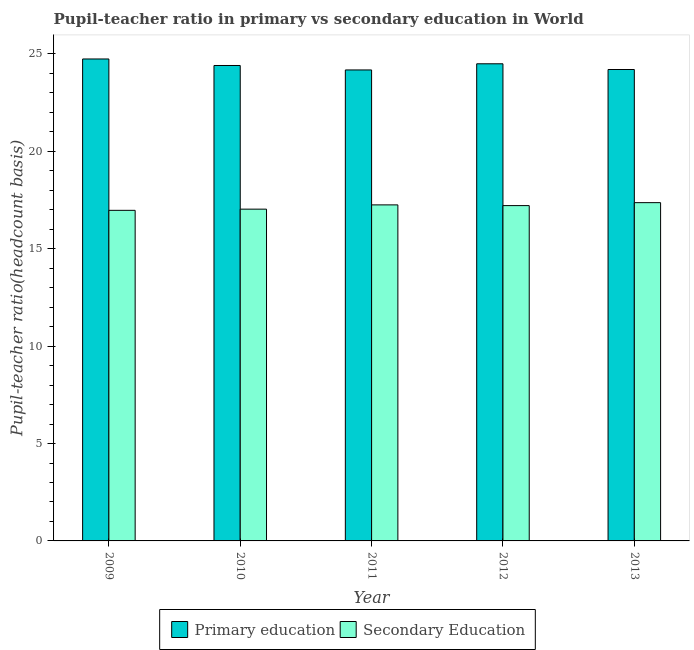How many different coloured bars are there?
Provide a short and direct response. 2. Are the number of bars per tick equal to the number of legend labels?
Ensure brevity in your answer.  Yes. Are the number of bars on each tick of the X-axis equal?
Your answer should be very brief. Yes. How many bars are there on the 4th tick from the right?
Offer a very short reply. 2. What is the pupil-teacher ratio in primary education in 2012?
Offer a terse response. 24.49. Across all years, what is the maximum pupil-teacher ratio in primary education?
Your answer should be very brief. 24.74. Across all years, what is the minimum pupil teacher ratio on secondary education?
Make the answer very short. 16.97. In which year was the pupil-teacher ratio in primary education minimum?
Offer a very short reply. 2011. What is the total pupil-teacher ratio in primary education in the graph?
Give a very brief answer. 122.02. What is the difference between the pupil-teacher ratio in primary education in 2009 and that in 2011?
Give a very brief answer. 0.56. What is the difference between the pupil teacher ratio on secondary education in 2009 and the pupil-teacher ratio in primary education in 2010?
Provide a succinct answer. -0.06. What is the average pupil teacher ratio on secondary education per year?
Give a very brief answer. 17.17. In how many years, is the pupil-teacher ratio in primary education greater than 7?
Provide a short and direct response. 5. What is the ratio of the pupil-teacher ratio in primary education in 2012 to that in 2013?
Your answer should be compact. 1.01. Is the difference between the pupil teacher ratio on secondary education in 2009 and 2012 greater than the difference between the pupil-teacher ratio in primary education in 2009 and 2012?
Give a very brief answer. No. What is the difference between the highest and the second highest pupil teacher ratio on secondary education?
Your response must be concise. 0.12. What is the difference between the highest and the lowest pupil-teacher ratio in primary education?
Make the answer very short. 0.56. What does the 2nd bar from the left in 2012 represents?
Give a very brief answer. Secondary Education. What does the 2nd bar from the right in 2013 represents?
Provide a short and direct response. Primary education. What is the difference between two consecutive major ticks on the Y-axis?
Your answer should be compact. 5. Are the values on the major ticks of Y-axis written in scientific E-notation?
Your answer should be compact. No. Does the graph contain grids?
Your answer should be very brief. No. Where does the legend appear in the graph?
Keep it short and to the point. Bottom center. How many legend labels are there?
Offer a very short reply. 2. What is the title of the graph?
Keep it short and to the point. Pupil-teacher ratio in primary vs secondary education in World. Does "Rural Population" appear as one of the legend labels in the graph?
Your response must be concise. No. What is the label or title of the Y-axis?
Provide a short and direct response. Pupil-teacher ratio(headcount basis). What is the Pupil-teacher ratio(headcount basis) of Primary education in 2009?
Ensure brevity in your answer.  24.74. What is the Pupil-teacher ratio(headcount basis) in Secondary Education in 2009?
Your answer should be compact. 16.97. What is the Pupil-teacher ratio(headcount basis) of Primary education in 2010?
Give a very brief answer. 24.41. What is the Pupil-teacher ratio(headcount basis) in Secondary Education in 2010?
Give a very brief answer. 17.03. What is the Pupil-teacher ratio(headcount basis) of Primary education in 2011?
Offer a very short reply. 24.18. What is the Pupil-teacher ratio(headcount basis) of Secondary Education in 2011?
Provide a succinct answer. 17.25. What is the Pupil-teacher ratio(headcount basis) of Primary education in 2012?
Offer a terse response. 24.49. What is the Pupil-teacher ratio(headcount basis) in Secondary Education in 2012?
Your answer should be compact. 17.21. What is the Pupil-teacher ratio(headcount basis) of Primary education in 2013?
Provide a short and direct response. 24.2. What is the Pupil-teacher ratio(headcount basis) in Secondary Education in 2013?
Provide a succinct answer. 17.37. Across all years, what is the maximum Pupil-teacher ratio(headcount basis) of Primary education?
Offer a very short reply. 24.74. Across all years, what is the maximum Pupil-teacher ratio(headcount basis) in Secondary Education?
Make the answer very short. 17.37. Across all years, what is the minimum Pupil-teacher ratio(headcount basis) of Primary education?
Your response must be concise. 24.18. Across all years, what is the minimum Pupil-teacher ratio(headcount basis) of Secondary Education?
Make the answer very short. 16.97. What is the total Pupil-teacher ratio(headcount basis) in Primary education in the graph?
Provide a succinct answer. 122.02. What is the total Pupil-teacher ratio(headcount basis) of Secondary Education in the graph?
Make the answer very short. 85.83. What is the difference between the Pupil-teacher ratio(headcount basis) of Primary education in 2009 and that in 2010?
Make the answer very short. 0.34. What is the difference between the Pupil-teacher ratio(headcount basis) of Secondary Education in 2009 and that in 2010?
Your answer should be very brief. -0.06. What is the difference between the Pupil-teacher ratio(headcount basis) in Primary education in 2009 and that in 2011?
Ensure brevity in your answer.  0.56. What is the difference between the Pupil-teacher ratio(headcount basis) in Secondary Education in 2009 and that in 2011?
Your response must be concise. -0.28. What is the difference between the Pupil-teacher ratio(headcount basis) of Primary education in 2009 and that in 2012?
Make the answer very short. 0.25. What is the difference between the Pupil-teacher ratio(headcount basis) of Secondary Education in 2009 and that in 2012?
Make the answer very short. -0.24. What is the difference between the Pupil-teacher ratio(headcount basis) of Primary education in 2009 and that in 2013?
Make the answer very short. 0.54. What is the difference between the Pupil-teacher ratio(headcount basis) of Secondary Education in 2009 and that in 2013?
Make the answer very short. -0.39. What is the difference between the Pupil-teacher ratio(headcount basis) in Primary education in 2010 and that in 2011?
Provide a succinct answer. 0.23. What is the difference between the Pupil-teacher ratio(headcount basis) of Secondary Education in 2010 and that in 2011?
Provide a short and direct response. -0.22. What is the difference between the Pupil-teacher ratio(headcount basis) in Primary education in 2010 and that in 2012?
Your response must be concise. -0.09. What is the difference between the Pupil-teacher ratio(headcount basis) of Secondary Education in 2010 and that in 2012?
Your answer should be compact. -0.18. What is the difference between the Pupil-teacher ratio(headcount basis) in Primary education in 2010 and that in 2013?
Give a very brief answer. 0.21. What is the difference between the Pupil-teacher ratio(headcount basis) of Secondary Education in 2010 and that in 2013?
Provide a succinct answer. -0.33. What is the difference between the Pupil-teacher ratio(headcount basis) in Primary education in 2011 and that in 2012?
Provide a succinct answer. -0.32. What is the difference between the Pupil-teacher ratio(headcount basis) of Secondary Education in 2011 and that in 2012?
Your answer should be very brief. 0.04. What is the difference between the Pupil-teacher ratio(headcount basis) in Primary education in 2011 and that in 2013?
Provide a short and direct response. -0.02. What is the difference between the Pupil-teacher ratio(headcount basis) in Secondary Education in 2011 and that in 2013?
Offer a terse response. -0.12. What is the difference between the Pupil-teacher ratio(headcount basis) in Primary education in 2012 and that in 2013?
Your answer should be very brief. 0.29. What is the difference between the Pupil-teacher ratio(headcount basis) of Secondary Education in 2012 and that in 2013?
Keep it short and to the point. -0.15. What is the difference between the Pupil-teacher ratio(headcount basis) of Primary education in 2009 and the Pupil-teacher ratio(headcount basis) of Secondary Education in 2010?
Keep it short and to the point. 7.71. What is the difference between the Pupil-teacher ratio(headcount basis) of Primary education in 2009 and the Pupil-teacher ratio(headcount basis) of Secondary Education in 2011?
Give a very brief answer. 7.49. What is the difference between the Pupil-teacher ratio(headcount basis) of Primary education in 2009 and the Pupil-teacher ratio(headcount basis) of Secondary Education in 2012?
Provide a succinct answer. 7.53. What is the difference between the Pupil-teacher ratio(headcount basis) of Primary education in 2009 and the Pupil-teacher ratio(headcount basis) of Secondary Education in 2013?
Your response must be concise. 7.38. What is the difference between the Pupil-teacher ratio(headcount basis) of Primary education in 2010 and the Pupil-teacher ratio(headcount basis) of Secondary Education in 2011?
Your answer should be compact. 7.16. What is the difference between the Pupil-teacher ratio(headcount basis) of Primary education in 2010 and the Pupil-teacher ratio(headcount basis) of Secondary Education in 2012?
Provide a succinct answer. 7.19. What is the difference between the Pupil-teacher ratio(headcount basis) of Primary education in 2010 and the Pupil-teacher ratio(headcount basis) of Secondary Education in 2013?
Make the answer very short. 7.04. What is the difference between the Pupil-teacher ratio(headcount basis) of Primary education in 2011 and the Pupil-teacher ratio(headcount basis) of Secondary Education in 2012?
Keep it short and to the point. 6.96. What is the difference between the Pupil-teacher ratio(headcount basis) in Primary education in 2011 and the Pupil-teacher ratio(headcount basis) in Secondary Education in 2013?
Provide a short and direct response. 6.81. What is the difference between the Pupil-teacher ratio(headcount basis) of Primary education in 2012 and the Pupil-teacher ratio(headcount basis) of Secondary Education in 2013?
Make the answer very short. 7.13. What is the average Pupil-teacher ratio(headcount basis) of Primary education per year?
Your response must be concise. 24.4. What is the average Pupil-teacher ratio(headcount basis) of Secondary Education per year?
Offer a terse response. 17.17. In the year 2009, what is the difference between the Pupil-teacher ratio(headcount basis) of Primary education and Pupil-teacher ratio(headcount basis) of Secondary Education?
Give a very brief answer. 7.77. In the year 2010, what is the difference between the Pupil-teacher ratio(headcount basis) of Primary education and Pupil-teacher ratio(headcount basis) of Secondary Education?
Ensure brevity in your answer.  7.37. In the year 2011, what is the difference between the Pupil-teacher ratio(headcount basis) of Primary education and Pupil-teacher ratio(headcount basis) of Secondary Education?
Offer a terse response. 6.93. In the year 2012, what is the difference between the Pupil-teacher ratio(headcount basis) in Primary education and Pupil-teacher ratio(headcount basis) in Secondary Education?
Offer a terse response. 7.28. In the year 2013, what is the difference between the Pupil-teacher ratio(headcount basis) in Primary education and Pupil-teacher ratio(headcount basis) in Secondary Education?
Your response must be concise. 6.84. What is the ratio of the Pupil-teacher ratio(headcount basis) in Primary education in 2009 to that in 2010?
Give a very brief answer. 1.01. What is the ratio of the Pupil-teacher ratio(headcount basis) of Secondary Education in 2009 to that in 2010?
Your answer should be very brief. 1. What is the ratio of the Pupil-teacher ratio(headcount basis) in Primary education in 2009 to that in 2011?
Provide a succinct answer. 1.02. What is the ratio of the Pupil-teacher ratio(headcount basis) in Secondary Education in 2009 to that in 2011?
Offer a terse response. 0.98. What is the ratio of the Pupil-teacher ratio(headcount basis) in Primary education in 2009 to that in 2012?
Your answer should be compact. 1.01. What is the ratio of the Pupil-teacher ratio(headcount basis) of Secondary Education in 2009 to that in 2012?
Give a very brief answer. 0.99. What is the ratio of the Pupil-teacher ratio(headcount basis) in Primary education in 2009 to that in 2013?
Make the answer very short. 1.02. What is the ratio of the Pupil-teacher ratio(headcount basis) in Secondary Education in 2009 to that in 2013?
Your response must be concise. 0.98. What is the ratio of the Pupil-teacher ratio(headcount basis) of Primary education in 2010 to that in 2011?
Your response must be concise. 1.01. What is the ratio of the Pupil-teacher ratio(headcount basis) of Secondary Education in 2010 to that in 2011?
Provide a short and direct response. 0.99. What is the ratio of the Pupil-teacher ratio(headcount basis) in Primary education in 2010 to that in 2013?
Keep it short and to the point. 1.01. What is the ratio of the Pupil-teacher ratio(headcount basis) in Secondary Education in 2010 to that in 2013?
Offer a very short reply. 0.98. What is the ratio of the Pupil-teacher ratio(headcount basis) in Primary education in 2011 to that in 2012?
Your answer should be very brief. 0.99. What is the ratio of the Pupil-teacher ratio(headcount basis) of Secondary Education in 2011 to that in 2012?
Your answer should be compact. 1. What is the ratio of the Pupil-teacher ratio(headcount basis) in Primary education in 2011 to that in 2013?
Your answer should be compact. 1. What is the ratio of the Pupil-teacher ratio(headcount basis) in Primary education in 2012 to that in 2013?
Provide a succinct answer. 1.01. What is the difference between the highest and the second highest Pupil-teacher ratio(headcount basis) of Primary education?
Your answer should be very brief. 0.25. What is the difference between the highest and the second highest Pupil-teacher ratio(headcount basis) of Secondary Education?
Ensure brevity in your answer.  0.12. What is the difference between the highest and the lowest Pupil-teacher ratio(headcount basis) of Primary education?
Offer a very short reply. 0.56. What is the difference between the highest and the lowest Pupil-teacher ratio(headcount basis) in Secondary Education?
Your response must be concise. 0.39. 